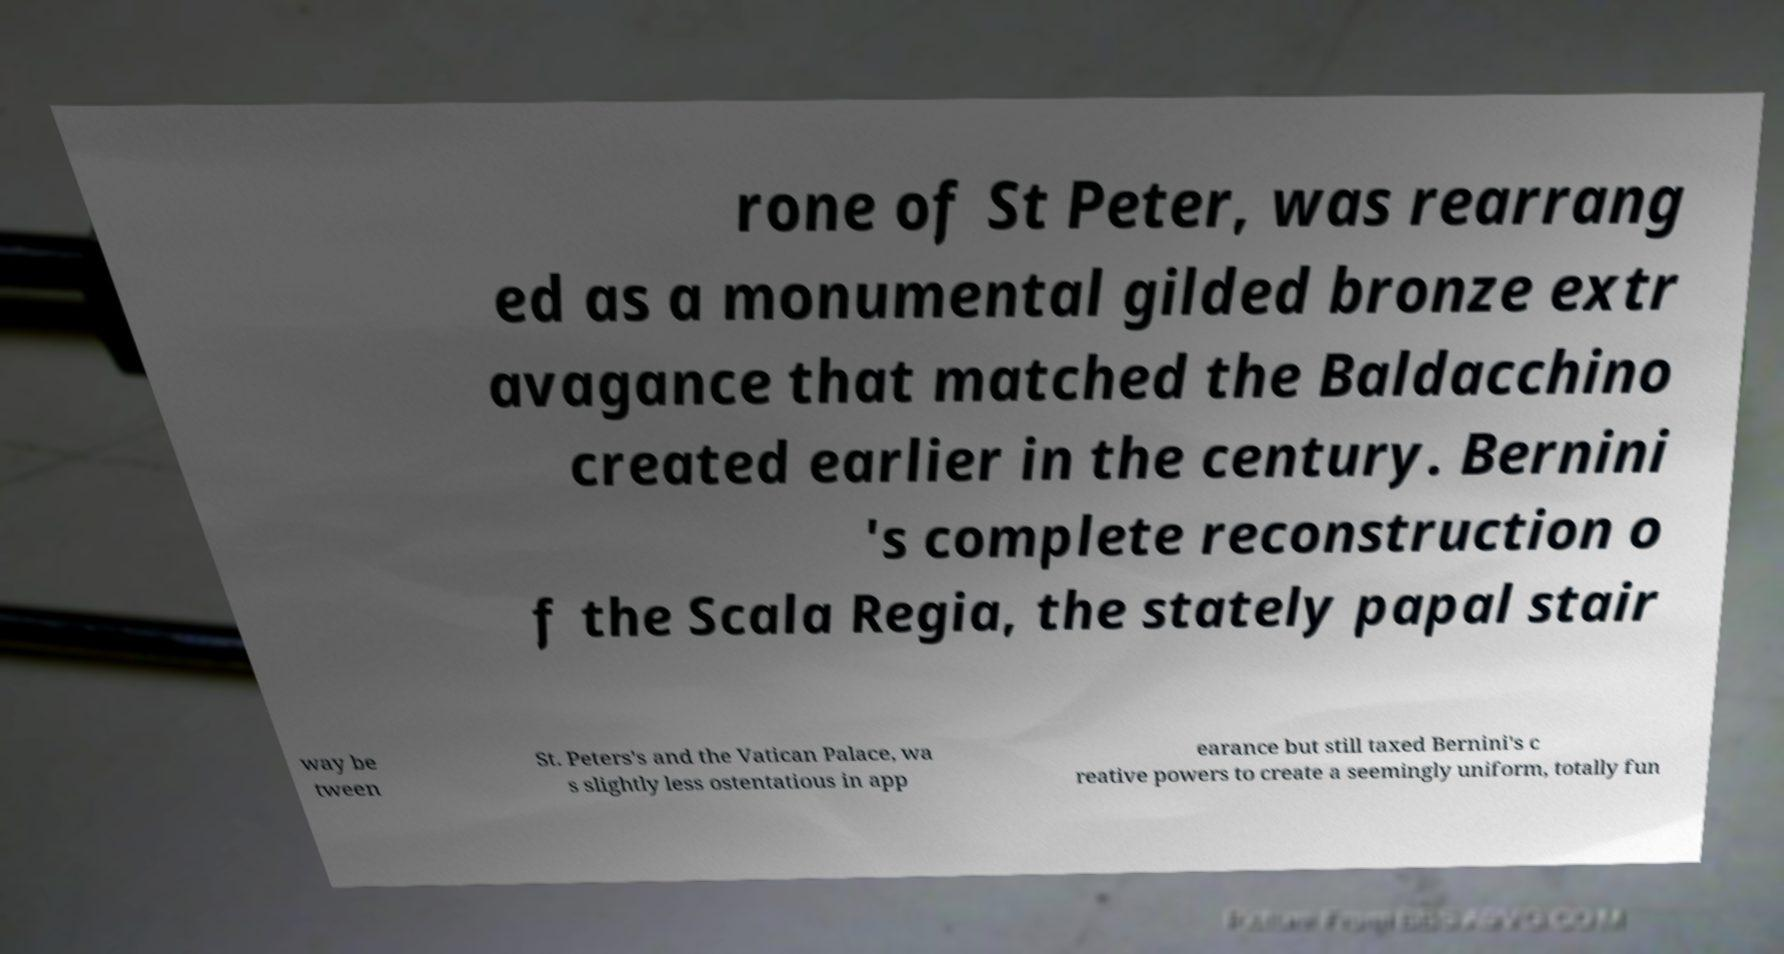Please identify and transcribe the text found in this image. rone of St Peter, was rearrang ed as a monumental gilded bronze extr avagance that matched the Baldacchino created earlier in the century. Bernini 's complete reconstruction o f the Scala Regia, the stately papal stair way be tween St. Peters's and the Vatican Palace, wa s slightly less ostentatious in app earance but still taxed Bernini's c reative powers to create a seemingly uniform, totally fun 